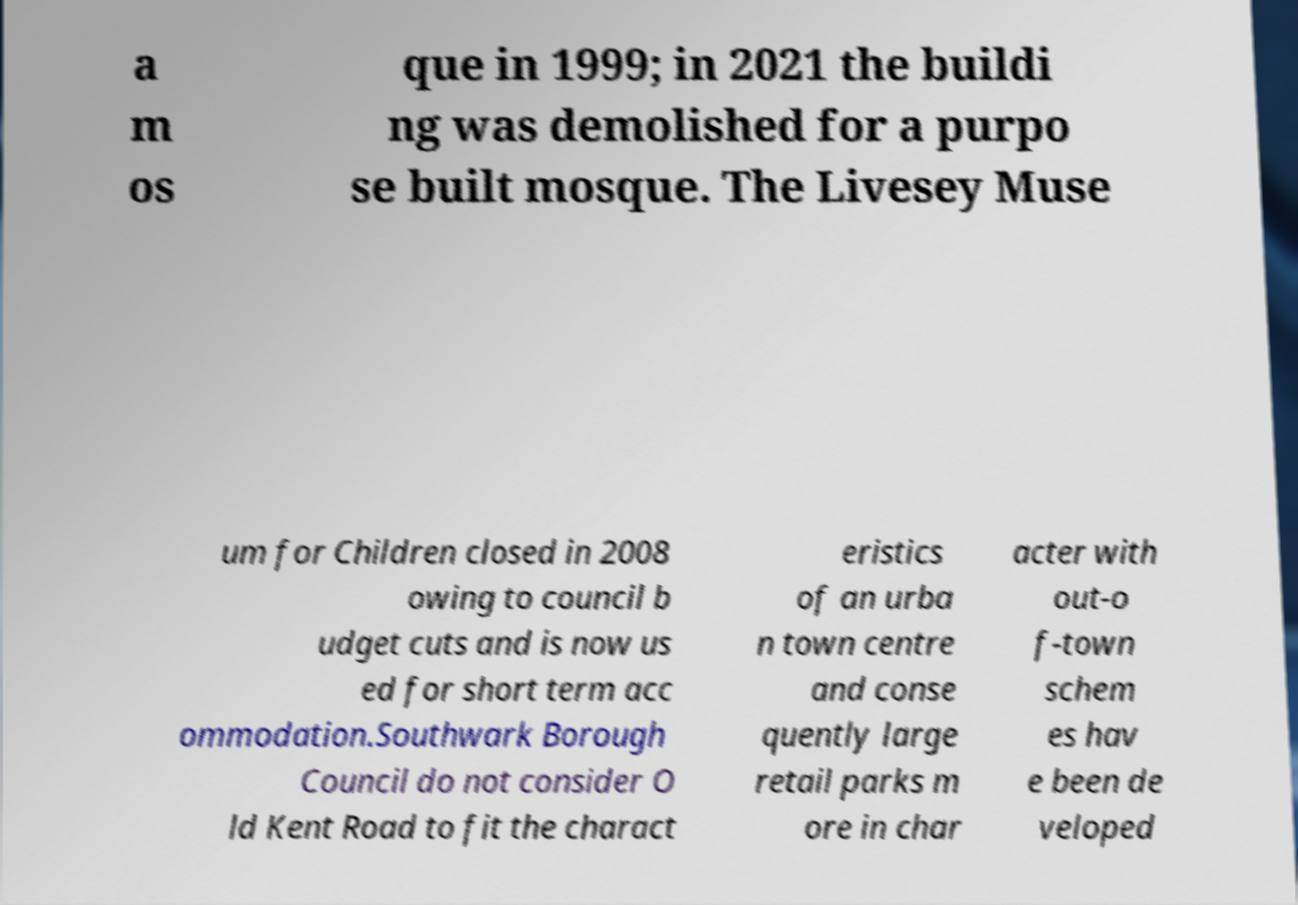Could you extract and type out the text from this image? a m os que in 1999; in 2021 the buildi ng was demolished for a purpo se built mosque. The Livesey Muse um for Children closed in 2008 owing to council b udget cuts and is now us ed for short term acc ommodation.Southwark Borough Council do not consider O ld Kent Road to fit the charact eristics of an urba n town centre and conse quently large retail parks m ore in char acter with out-o f-town schem es hav e been de veloped 